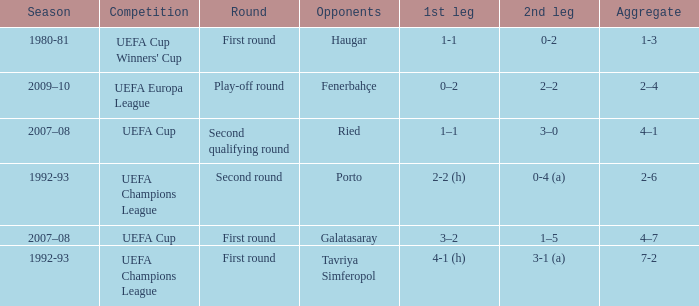 what's the competition where 1st leg is 4-1 (h) UEFA Champions League. 